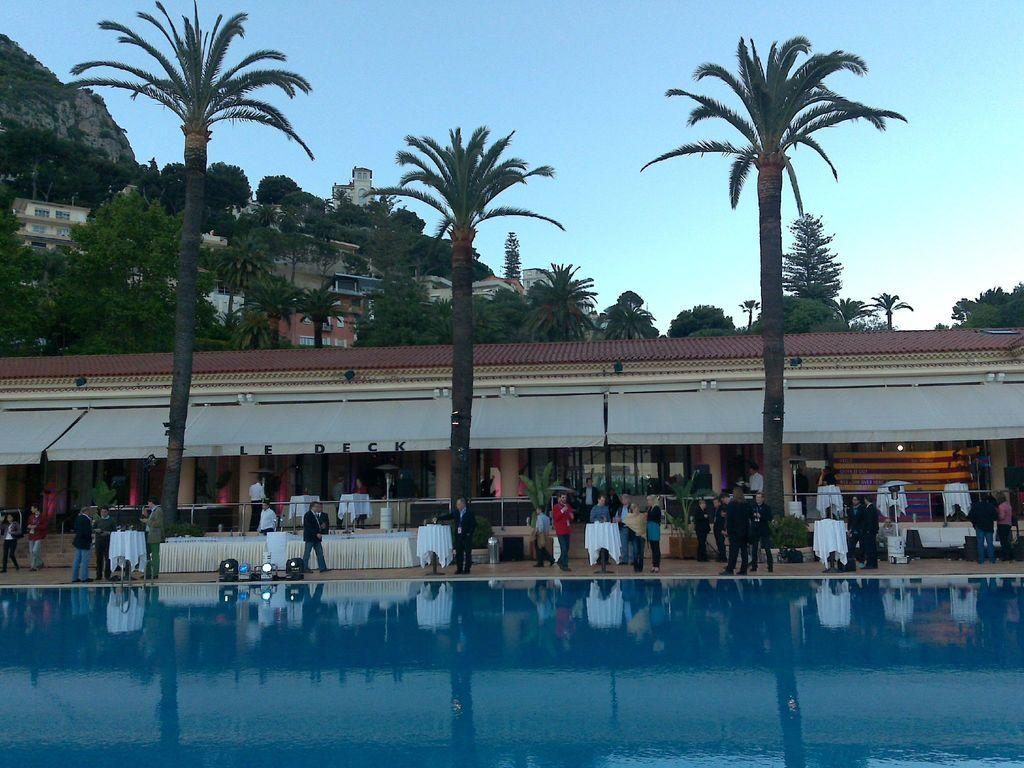What type of structures can be seen in the image? There are buildings in the image. What natural feature is present in the image? There is a hill in the image. What type of vegetation is visible in the image? There are trees in the image. What type of furniture is present in the image? There are tables in the image. What type of illumination is present in the image? There are lights in the image. What type of water feature is present in the image? There is a pool at the bottom of the image. Are there any people present in the image? Yes, there are people in the image. What part of the natural environment is visible in the image? The sky is visible in the image. What type of knife is being used by the people in the image? There is no knife present in the image; the people are not using any knives. What type of party is being held in the image? There is no party present in the image; it is a scene with buildings, a hill, trees, tables, lights, a pool, and people. 